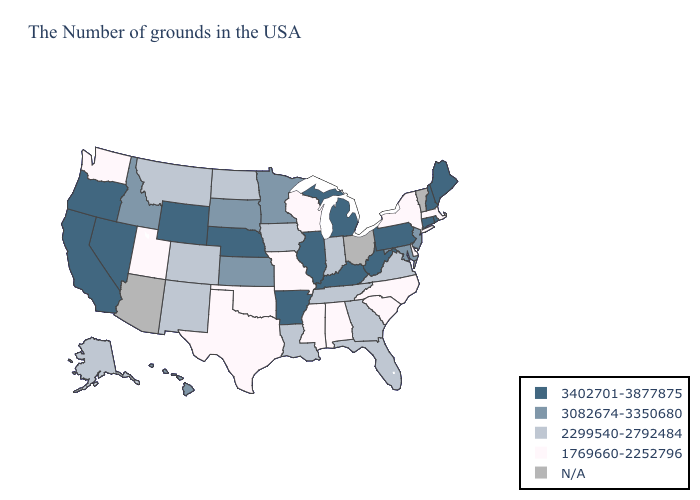What is the value of Mississippi?
Answer briefly. 1769660-2252796. Name the states that have a value in the range 3402701-3877875?
Keep it brief. Maine, Rhode Island, New Hampshire, Connecticut, Pennsylvania, West Virginia, Michigan, Kentucky, Illinois, Arkansas, Nebraska, Wyoming, Nevada, California, Oregon. Name the states that have a value in the range 3402701-3877875?
Be succinct. Maine, Rhode Island, New Hampshire, Connecticut, Pennsylvania, West Virginia, Michigan, Kentucky, Illinois, Arkansas, Nebraska, Wyoming, Nevada, California, Oregon. What is the value of Georgia?
Write a very short answer. 2299540-2792484. What is the highest value in the MidWest ?
Quick response, please. 3402701-3877875. Name the states that have a value in the range 2299540-2792484?
Concise answer only. Virginia, Florida, Georgia, Indiana, Tennessee, Louisiana, Iowa, North Dakota, Colorado, New Mexico, Montana, Alaska. What is the lowest value in the USA?
Keep it brief. 1769660-2252796. Name the states that have a value in the range N/A?
Give a very brief answer. Vermont, Ohio, Arizona. Name the states that have a value in the range N/A?
Write a very short answer. Vermont, Ohio, Arizona. What is the lowest value in the South?
Keep it brief. 1769660-2252796. Name the states that have a value in the range 3402701-3877875?
Write a very short answer. Maine, Rhode Island, New Hampshire, Connecticut, Pennsylvania, West Virginia, Michigan, Kentucky, Illinois, Arkansas, Nebraska, Wyoming, Nevada, California, Oregon. Does Oregon have the highest value in the USA?
Quick response, please. Yes. What is the value of North Carolina?
Give a very brief answer. 1769660-2252796. 